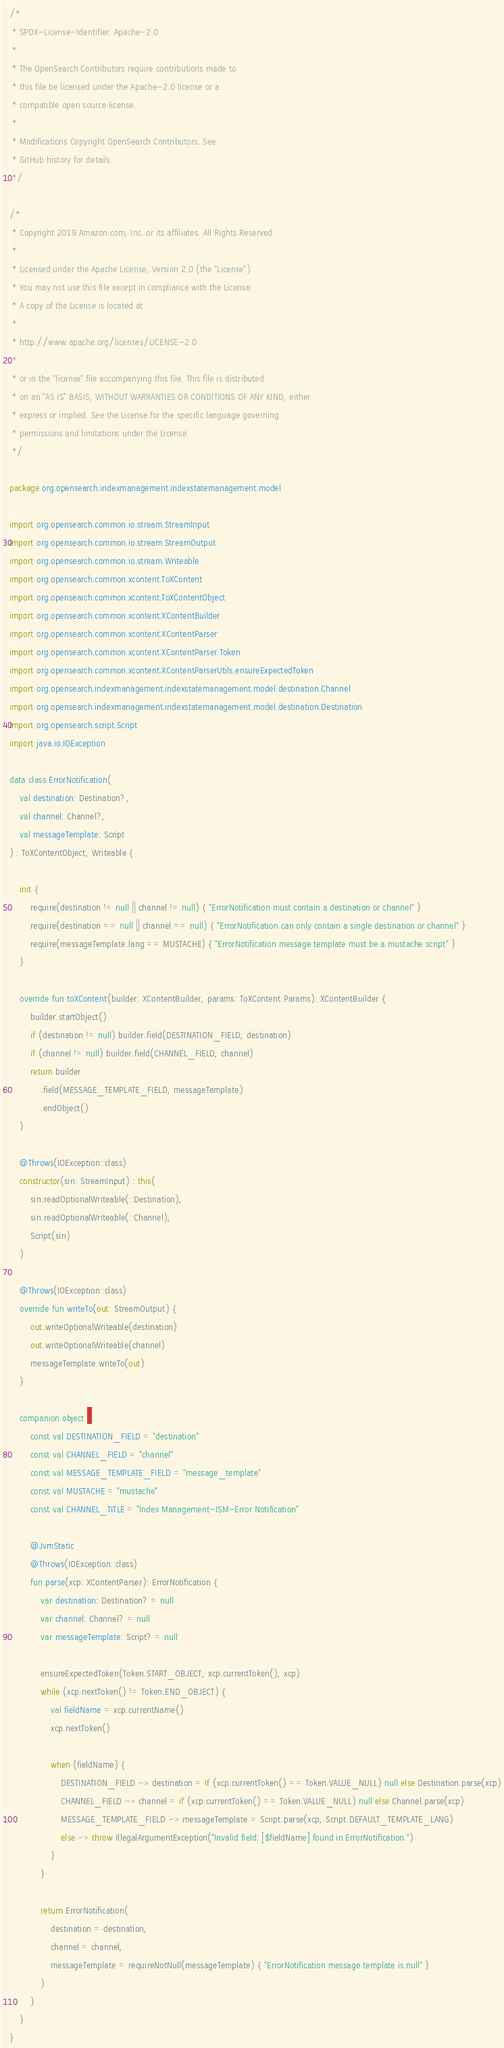Convert code to text. <code><loc_0><loc_0><loc_500><loc_500><_Kotlin_>/*
 * SPDX-License-Identifier: Apache-2.0
 *
 * The OpenSearch Contributors require contributions made to
 * this file be licensed under the Apache-2.0 license or a
 * compatible open source license.
 *
 * Modifications Copyright OpenSearch Contributors. See
 * GitHub history for details.
 */

/*
 * Copyright 2019 Amazon.com, Inc. or its affiliates. All Rights Reserved.
 *
 * Licensed under the Apache License, Version 2.0 (the "License").
 * You may not use this file except in compliance with the License.
 * A copy of the License is located at
 *
 * http://www.apache.org/licenses/LICENSE-2.0
 *
 * or in the "license" file accompanying this file. This file is distributed
 * on an "AS IS" BASIS, WITHOUT WARRANTIES OR CONDITIONS OF ANY KIND, either
 * express or implied. See the License for the specific language governing
 * permissions and limitations under the License.
 */

package org.opensearch.indexmanagement.indexstatemanagement.model

import org.opensearch.common.io.stream.StreamInput
import org.opensearch.common.io.stream.StreamOutput
import org.opensearch.common.io.stream.Writeable
import org.opensearch.common.xcontent.ToXContent
import org.opensearch.common.xcontent.ToXContentObject
import org.opensearch.common.xcontent.XContentBuilder
import org.opensearch.common.xcontent.XContentParser
import org.opensearch.common.xcontent.XContentParser.Token
import org.opensearch.common.xcontent.XContentParserUtils.ensureExpectedToken
import org.opensearch.indexmanagement.indexstatemanagement.model.destination.Channel
import org.opensearch.indexmanagement.indexstatemanagement.model.destination.Destination
import org.opensearch.script.Script
import java.io.IOException

data class ErrorNotification(
    val destination: Destination?,
    val channel: Channel?,
    val messageTemplate: Script
) : ToXContentObject, Writeable {

    init {
        require(destination != null || channel != null) { "ErrorNotification must contain a destination or channel" }
        require(destination == null || channel == null) { "ErrorNotification can only contain a single destination or channel" }
        require(messageTemplate.lang == MUSTACHE) { "ErrorNotification message template must be a mustache script" }
    }

    override fun toXContent(builder: XContentBuilder, params: ToXContent.Params): XContentBuilder {
        builder.startObject()
        if (destination != null) builder.field(DESTINATION_FIELD, destination)
        if (channel != null) builder.field(CHANNEL_FIELD, channel)
        return builder
            .field(MESSAGE_TEMPLATE_FIELD, messageTemplate)
            .endObject()
    }

    @Throws(IOException::class)
    constructor(sin: StreamInput) : this(
        sin.readOptionalWriteable(::Destination),
        sin.readOptionalWriteable(::Channel),
        Script(sin)
    )

    @Throws(IOException::class)
    override fun writeTo(out: StreamOutput) {
        out.writeOptionalWriteable(destination)
        out.writeOptionalWriteable(channel)
        messageTemplate.writeTo(out)
    }

    companion object {
        const val DESTINATION_FIELD = "destination"
        const val CHANNEL_FIELD = "channel"
        const val MESSAGE_TEMPLATE_FIELD = "message_template"
        const val MUSTACHE = "mustache"
        const val CHANNEL_TITLE = "Index Management-ISM-Error Notification"

        @JvmStatic
        @Throws(IOException::class)
        fun parse(xcp: XContentParser): ErrorNotification {
            var destination: Destination? = null
            var channel: Channel? = null
            var messageTemplate: Script? = null

            ensureExpectedToken(Token.START_OBJECT, xcp.currentToken(), xcp)
            while (xcp.nextToken() != Token.END_OBJECT) {
                val fieldName = xcp.currentName()
                xcp.nextToken()

                when (fieldName) {
                    DESTINATION_FIELD -> destination = if (xcp.currentToken() == Token.VALUE_NULL) null else Destination.parse(xcp)
                    CHANNEL_FIELD -> channel = if (xcp.currentToken() == Token.VALUE_NULL) null else Channel.parse(xcp)
                    MESSAGE_TEMPLATE_FIELD -> messageTemplate = Script.parse(xcp, Script.DEFAULT_TEMPLATE_LANG)
                    else -> throw IllegalArgumentException("Invalid field: [$fieldName] found in ErrorNotification.")
                }
            }

            return ErrorNotification(
                destination = destination,
                channel = channel,
                messageTemplate = requireNotNull(messageTemplate) { "ErrorNotification message template is null" }
            )
        }
    }
}
</code> 